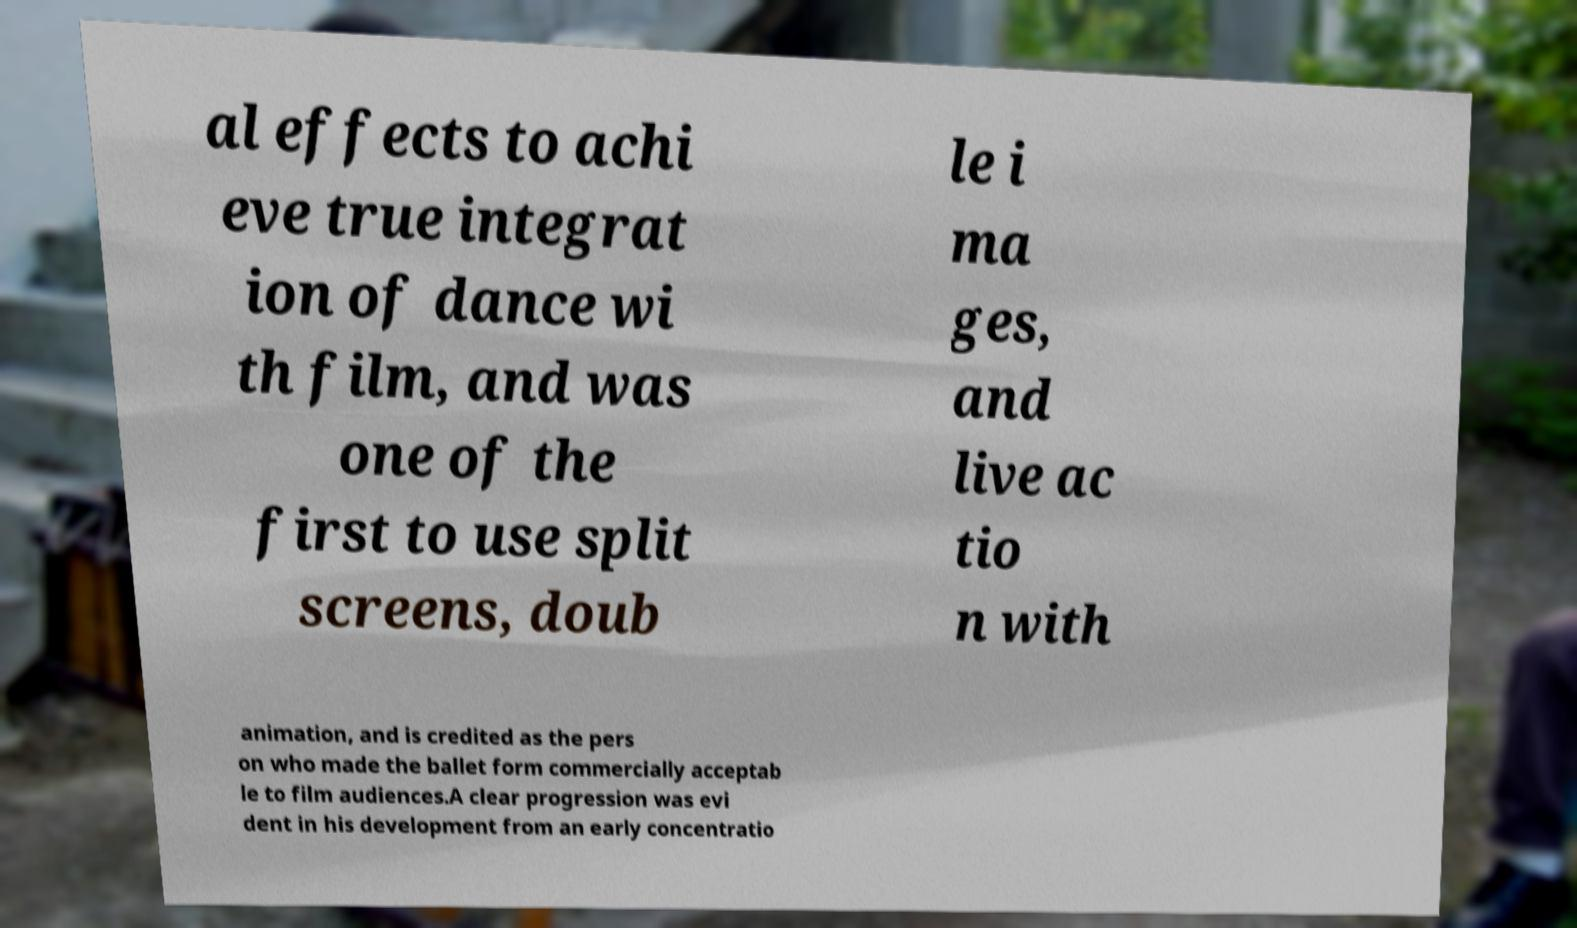Could you extract and type out the text from this image? al effects to achi eve true integrat ion of dance wi th film, and was one of the first to use split screens, doub le i ma ges, and live ac tio n with animation, and is credited as the pers on who made the ballet form commercially acceptab le to film audiences.A clear progression was evi dent in his development from an early concentratio 